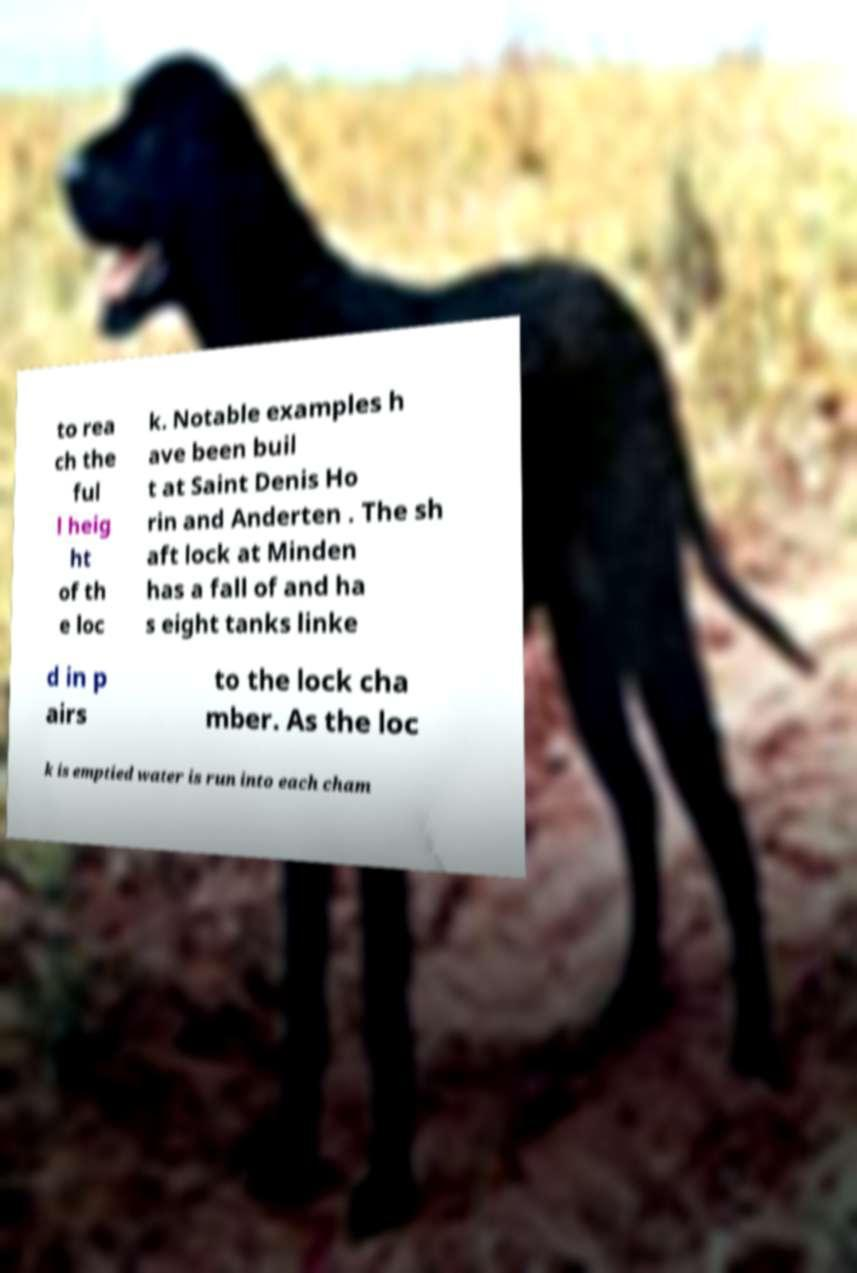Can you read and provide the text displayed in the image?This photo seems to have some interesting text. Can you extract and type it out for me? to rea ch the ful l heig ht of th e loc k. Notable examples h ave been buil t at Saint Denis Ho rin and Anderten . The sh aft lock at Minden has a fall of and ha s eight tanks linke d in p airs to the lock cha mber. As the loc k is emptied water is run into each cham 